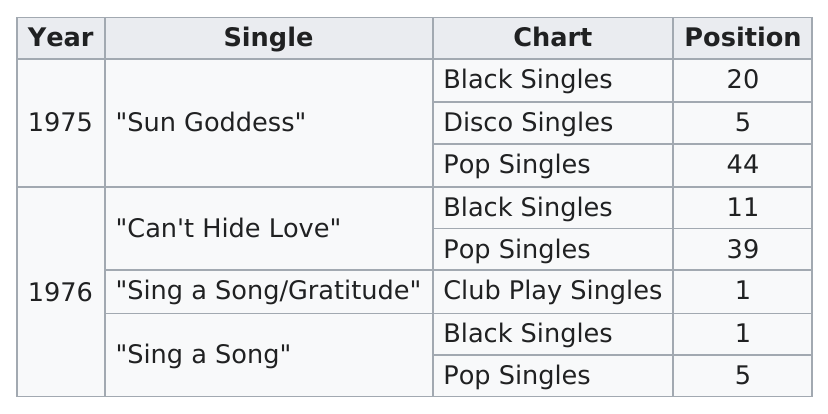Identify some key points in this picture. Out of the singles, 3 are included in the chart of pop singles. The song "Can't Hide Love" by a solo artist is currently ranked first among all other black singles on the chart, holding a position of 11. Of the singles that ranked in the top 1 position, the number that were in that position was 2. 